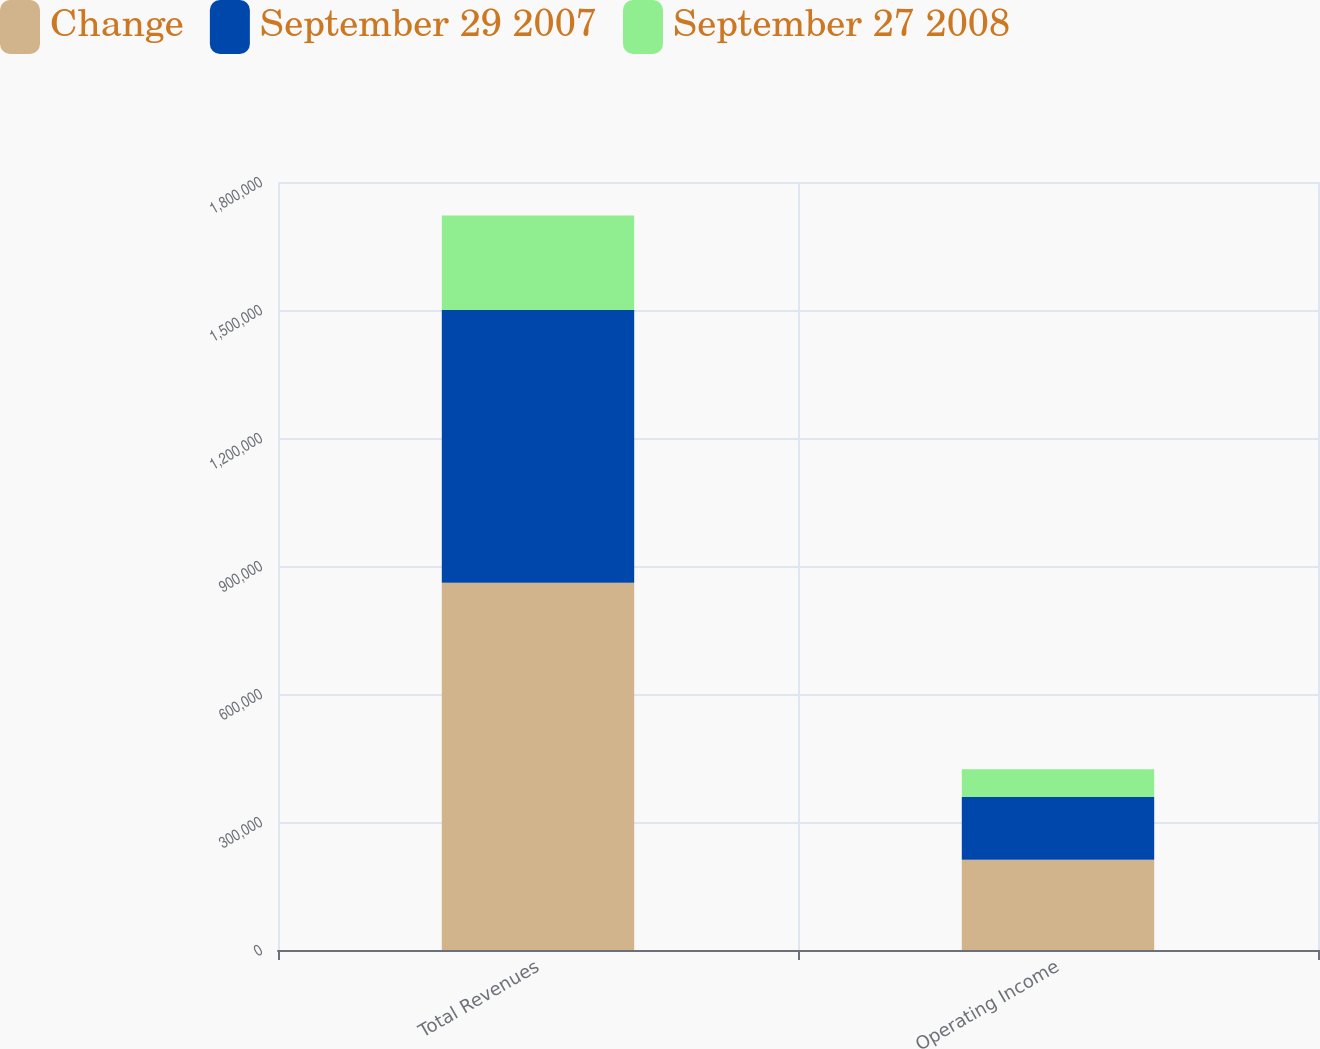<chart> <loc_0><loc_0><loc_500><loc_500><stacked_bar_chart><ecel><fcel>Total Revenues<fcel>Operating Income<nl><fcel>Change<fcel>860848<fcel>211704<nl><fcel>September 29 2007<fcel>638898<fcel>146907<nl><fcel>September 27 2008<fcel>221950<fcel>64797<nl></chart> 